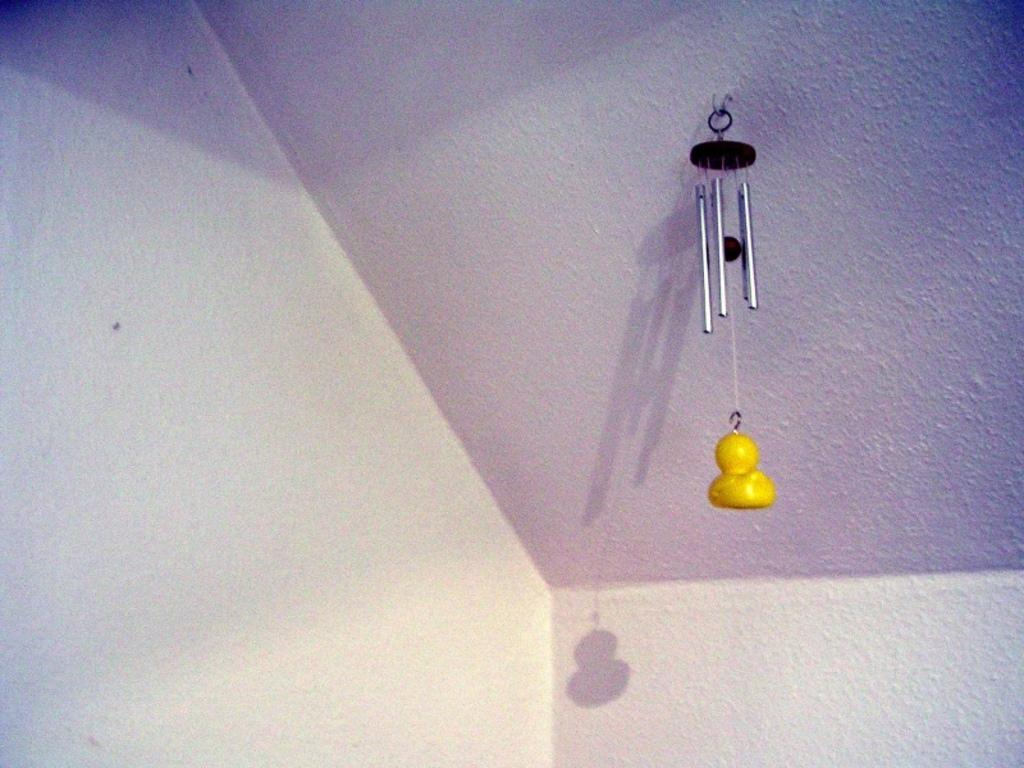What color is the object that can be seen in the image? The object in the image is yellow. What can be found on the ceiling in the image? There are pipes on the ceiling in the image. What can be observed in the background of the image? Shadows are visible in the background of the image. What type of underwear is the grandfather wearing in the image? There is no grandfather or underwear present in the image. What kind of lace is draped over the yellow object in the image? There is no lace present in the image; the yellow object is not covered or adorned with any fabric. 